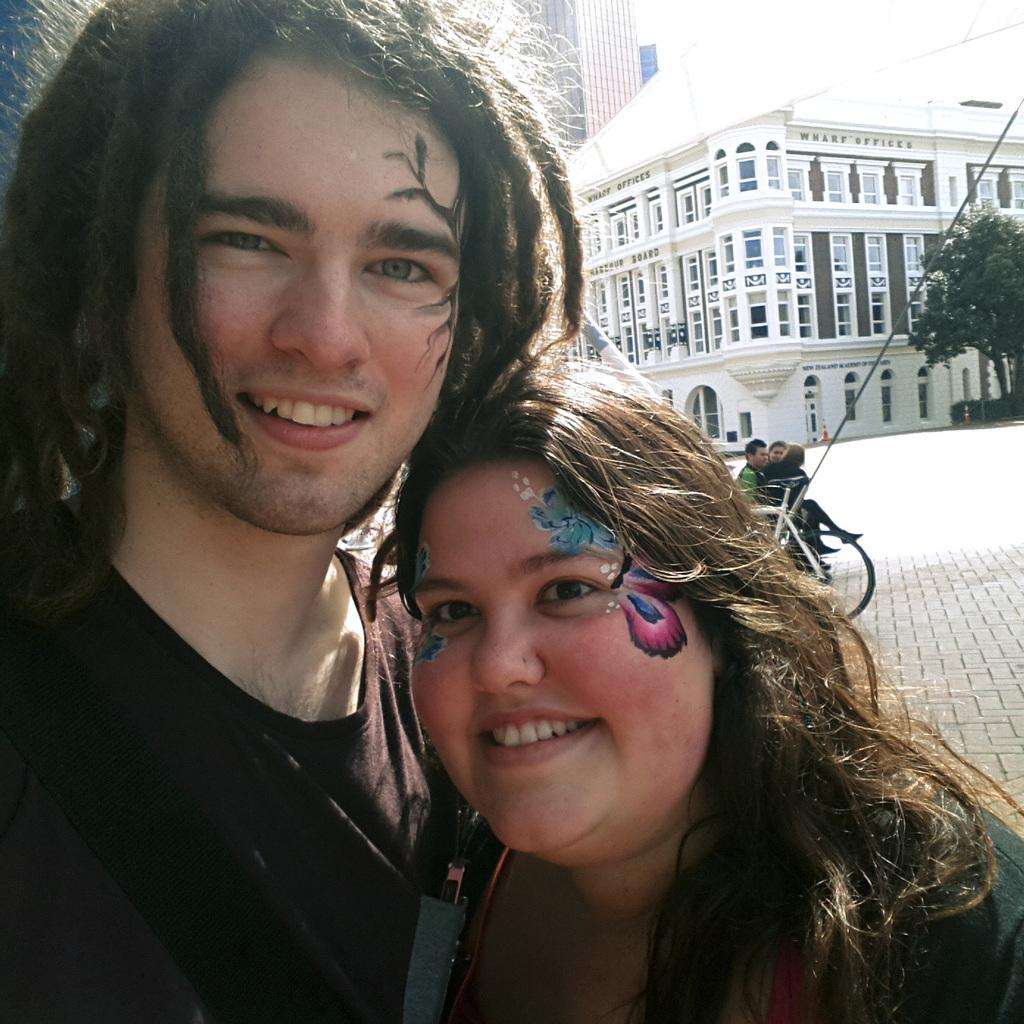How many people are present in the image? There are two people, a man and a woman, present in the image. What is the mode of transportation in the image? There is a vehicle in the image. What are the people in the image doing? There are people sitting in the image. What structures can be seen in the background of the image? There are buildings in the image. What type of vegetation is visible in the image? There is a tree in the image. What else can be seen in the image besides the people and the vehicle? There are poles in the image. What type of blade is being used to cut the tree in the image? There is no blade or tree-cutting activity present in the image. 